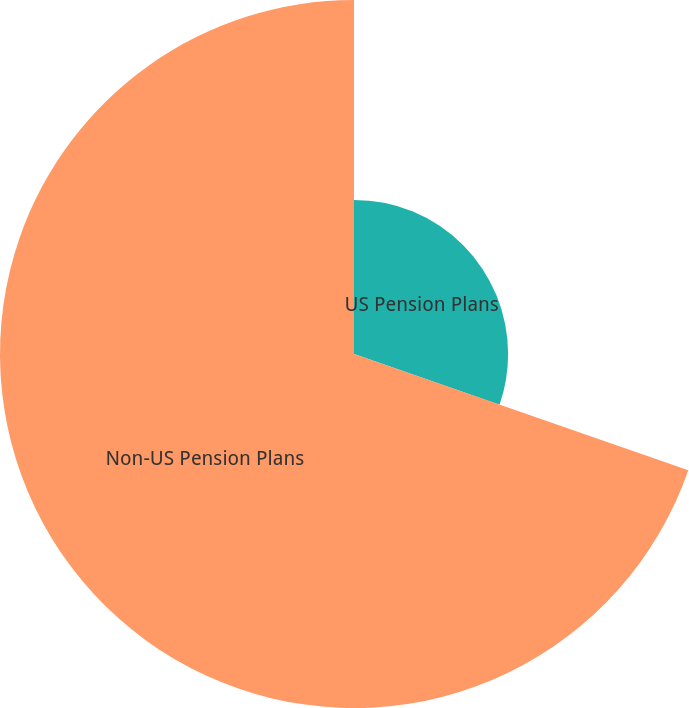Convert chart. <chart><loc_0><loc_0><loc_500><loc_500><pie_chart><fcel>US Pension Plans<fcel>Non-US Pension Plans<nl><fcel>30.33%<fcel>69.67%<nl></chart> 